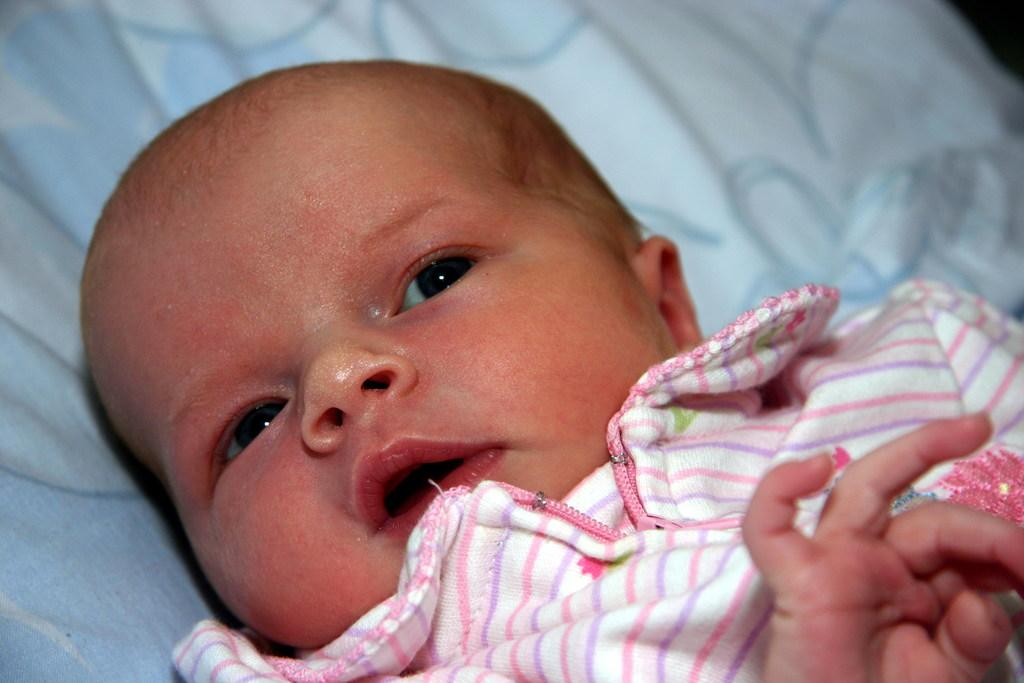What is the main subject of the image? There is a baby in the image. Can you describe anything in the background of the image? There is a cloth visible in the background of the image. How many ducks are crossing the road in the image? There are no ducks or roads present in the image; it features a baby and a cloth in the background. 